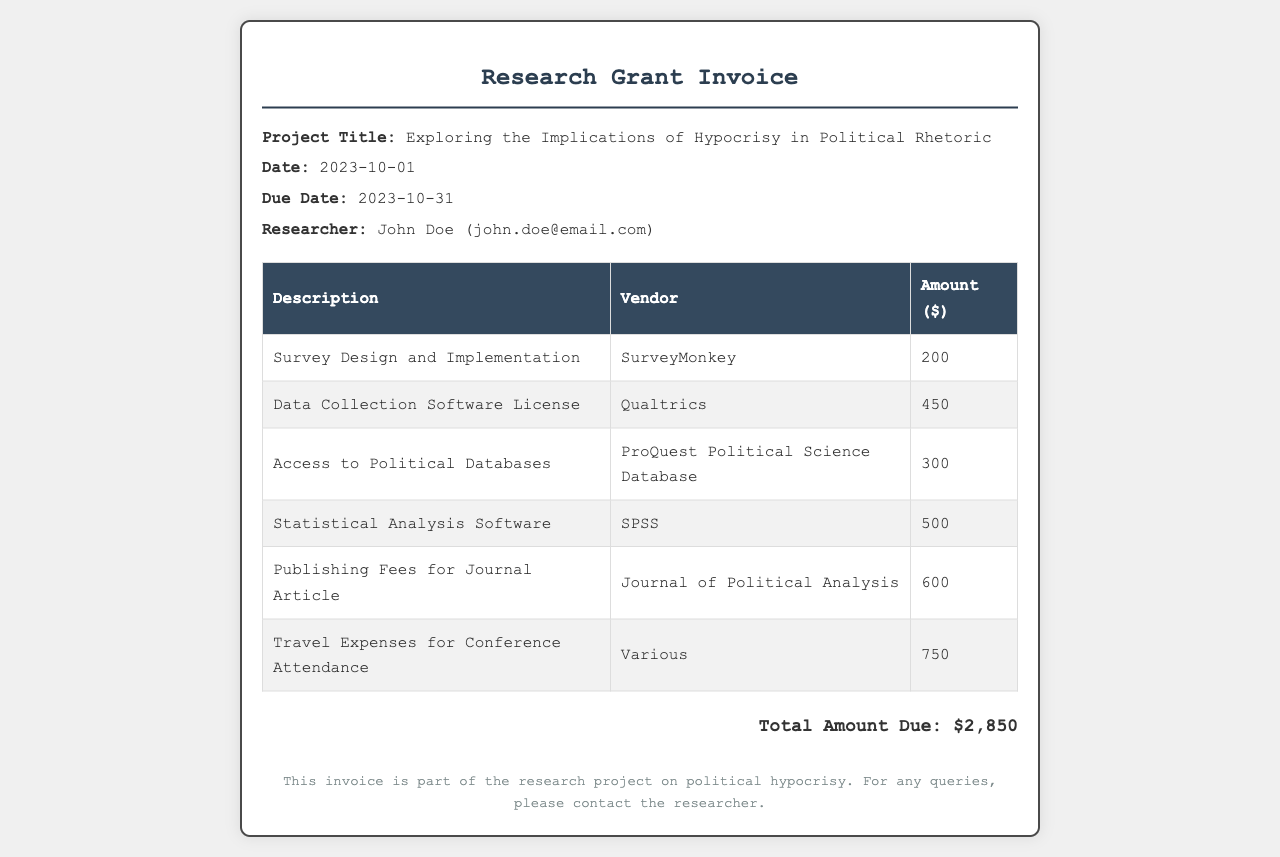What is the project title? The project title is explicitly mentioned in the document, which is "Exploring the Implications of Hypocrisy in Political Rhetoric."
Answer: Exploring the Implications of Hypocrisy in Political Rhetoric What is the total amount due? The total amount due is calculated at the bottom of the invoice, which sums up all the itemized expenses.
Answer: $2,850 Who is the researcher? The researcher’s name is provided in the project info section of the document, as John Doe.
Answer: John Doe What is the due date of the invoice? The due date is specified in the project information section of the document.
Answer: 2023-10-31 What was the expense for the Statistical Analysis Software? The expense for the Statistical Analysis Software is listed in the table of expenses, specifically for SPSS.
Answer: $500 How many itemized expenses are listed? The number of itemized expenses can be counted from the table in the document.
Answer: 6 What is the vendor for the Data Collection Software License? The vendor's name is noted in the expense table directly beside the corresponding expense.
Answer: Qualtrics What was the amount spent on Travel Expenses for Conference Attendance? The amount spent on travel expenses is clearly shown in the expense table.
Answer: $750 What database was accessed for political data collection? The name of the database is provided in the expense table associated with accessing political databases.
Answer: ProQuest Political Science Database 